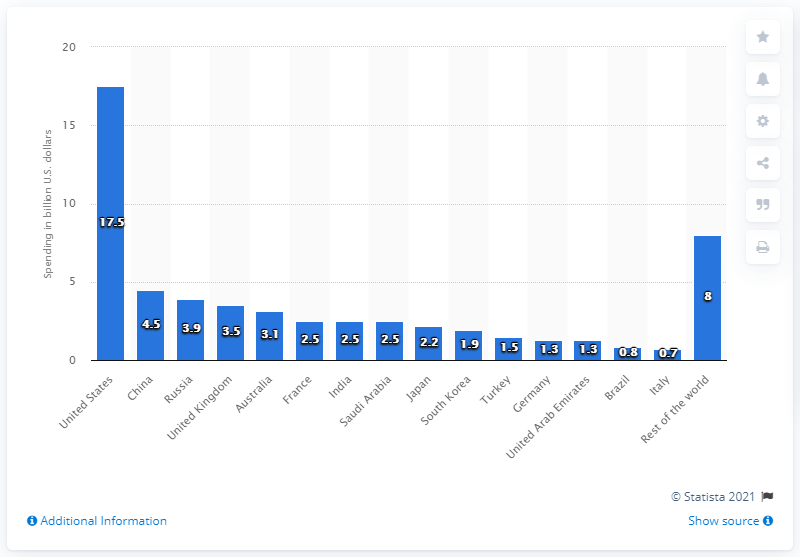How much money is the United States projected to spend on drones between 2017 and 2021? The United States is projected to spend approximately $17.5 billion on drones between 2017 and 2021, according to the data presented in the chart. 